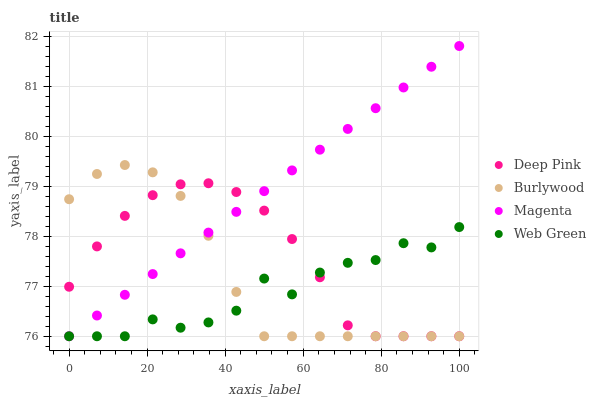Does Web Green have the minimum area under the curve?
Answer yes or no. Yes. Does Magenta have the maximum area under the curve?
Answer yes or no. Yes. Does Deep Pink have the minimum area under the curve?
Answer yes or no. No. Does Deep Pink have the maximum area under the curve?
Answer yes or no. No. Is Magenta the smoothest?
Answer yes or no. Yes. Is Web Green the roughest?
Answer yes or no. Yes. Is Deep Pink the smoothest?
Answer yes or no. No. Is Deep Pink the roughest?
Answer yes or no. No. Does Burlywood have the lowest value?
Answer yes or no. Yes. Does Magenta have the highest value?
Answer yes or no. Yes. Does Deep Pink have the highest value?
Answer yes or no. No. Does Deep Pink intersect Web Green?
Answer yes or no. Yes. Is Deep Pink less than Web Green?
Answer yes or no. No. Is Deep Pink greater than Web Green?
Answer yes or no. No. 